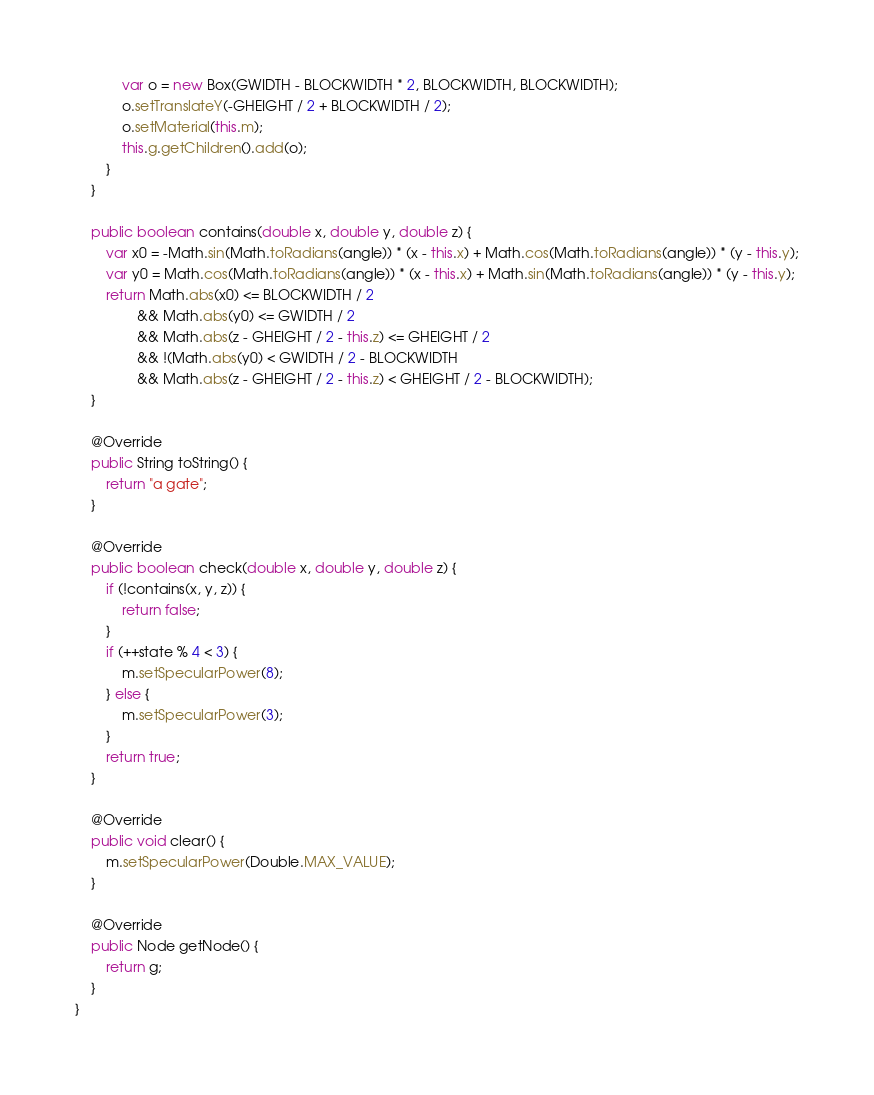Convert code to text. <code><loc_0><loc_0><loc_500><loc_500><_Java_>            var o = new Box(GWIDTH - BLOCKWIDTH * 2, BLOCKWIDTH, BLOCKWIDTH);
            o.setTranslateY(-GHEIGHT / 2 + BLOCKWIDTH / 2);
            o.setMaterial(this.m);
            this.g.getChildren().add(o);
        }
    }

    public boolean contains(double x, double y, double z) {
        var x0 = -Math.sin(Math.toRadians(angle)) * (x - this.x) + Math.cos(Math.toRadians(angle)) * (y - this.y);
        var y0 = Math.cos(Math.toRadians(angle)) * (x - this.x) + Math.sin(Math.toRadians(angle)) * (y - this.y);
        return Math.abs(x0) <= BLOCKWIDTH / 2
                && Math.abs(y0) <= GWIDTH / 2
                && Math.abs(z - GHEIGHT / 2 - this.z) <= GHEIGHT / 2
                && !(Math.abs(y0) < GWIDTH / 2 - BLOCKWIDTH
                && Math.abs(z - GHEIGHT / 2 - this.z) < GHEIGHT / 2 - BLOCKWIDTH);
    }

    @Override
    public String toString() {
        return "a gate";
    }

    @Override
    public boolean check(double x, double y, double z) {
        if (!contains(x, y, z)) {
            return false;
        }
        if (++state % 4 < 3) {
            m.setSpecularPower(8);
        } else {
            m.setSpecularPower(3);
        }
        return true;
    }

    @Override
    public void clear() {
        m.setSpecularPower(Double.MAX_VALUE);
    }

    @Override
    public Node getNode() {
        return g;
    }
}
</code> 